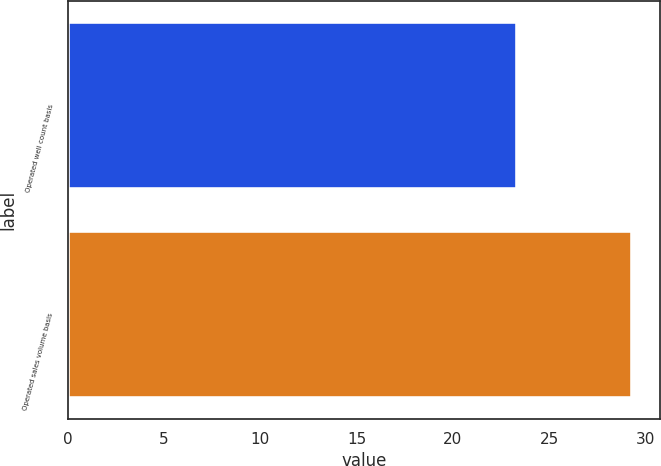<chart> <loc_0><loc_0><loc_500><loc_500><bar_chart><fcel>Operated well count basis<fcel>Operated sales volume basis<nl><fcel>23.3<fcel>29.3<nl></chart> 